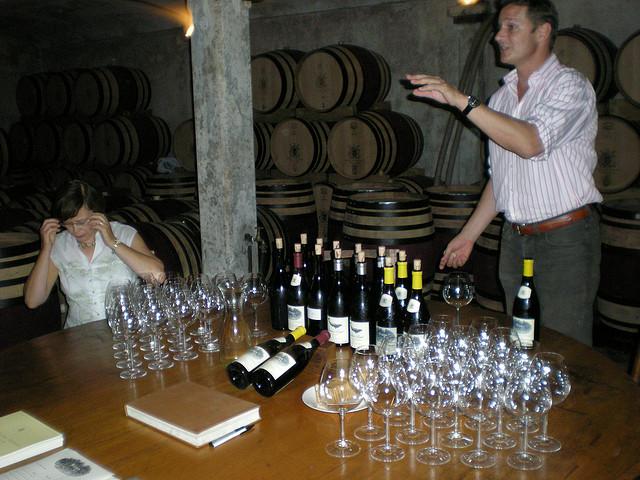What is in barrel?
Keep it brief. Wine. What event might this be?
Be succinct. Wine tasting. What is in the glasses?
Concise answer only. Nothing. 